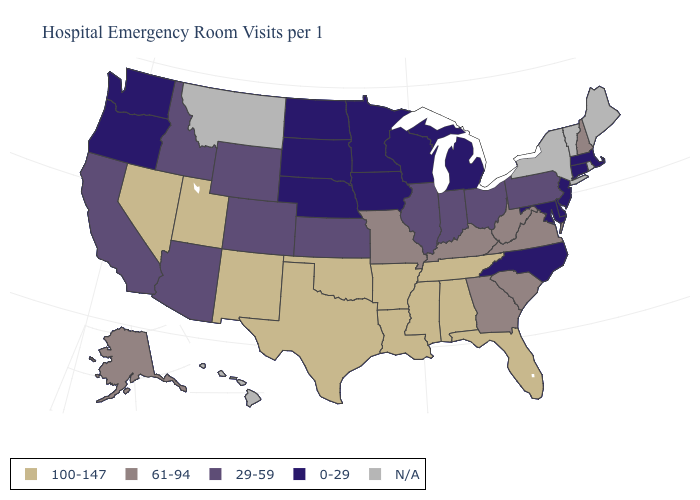What is the highest value in the MidWest ?
Quick response, please. 61-94. Is the legend a continuous bar?
Write a very short answer. No. Name the states that have a value in the range N/A?
Quick response, please. Hawaii, Maine, Montana, New York, Rhode Island, Vermont. What is the lowest value in the USA?
Be succinct. 0-29. Name the states that have a value in the range 61-94?
Concise answer only. Alaska, Georgia, Kentucky, Missouri, New Hampshire, South Carolina, Virginia, West Virginia. Name the states that have a value in the range 61-94?
Be succinct. Alaska, Georgia, Kentucky, Missouri, New Hampshire, South Carolina, Virginia, West Virginia. Name the states that have a value in the range 61-94?
Answer briefly. Alaska, Georgia, Kentucky, Missouri, New Hampshire, South Carolina, Virginia, West Virginia. Name the states that have a value in the range 61-94?
Answer briefly. Alaska, Georgia, Kentucky, Missouri, New Hampshire, South Carolina, Virginia, West Virginia. Name the states that have a value in the range 0-29?
Answer briefly. Connecticut, Delaware, Iowa, Maryland, Massachusetts, Michigan, Minnesota, Nebraska, New Jersey, North Carolina, North Dakota, Oregon, South Dakota, Washington, Wisconsin. What is the highest value in the USA?
Answer briefly. 100-147. Name the states that have a value in the range 29-59?
Quick response, please. Arizona, California, Colorado, Idaho, Illinois, Indiana, Kansas, Ohio, Pennsylvania, Wyoming. How many symbols are there in the legend?
Concise answer only. 5. Which states hav the highest value in the Northeast?
Concise answer only. New Hampshire. Name the states that have a value in the range 0-29?
Write a very short answer. Connecticut, Delaware, Iowa, Maryland, Massachusetts, Michigan, Minnesota, Nebraska, New Jersey, North Carolina, North Dakota, Oregon, South Dakota, Washington, Wisconsin. 